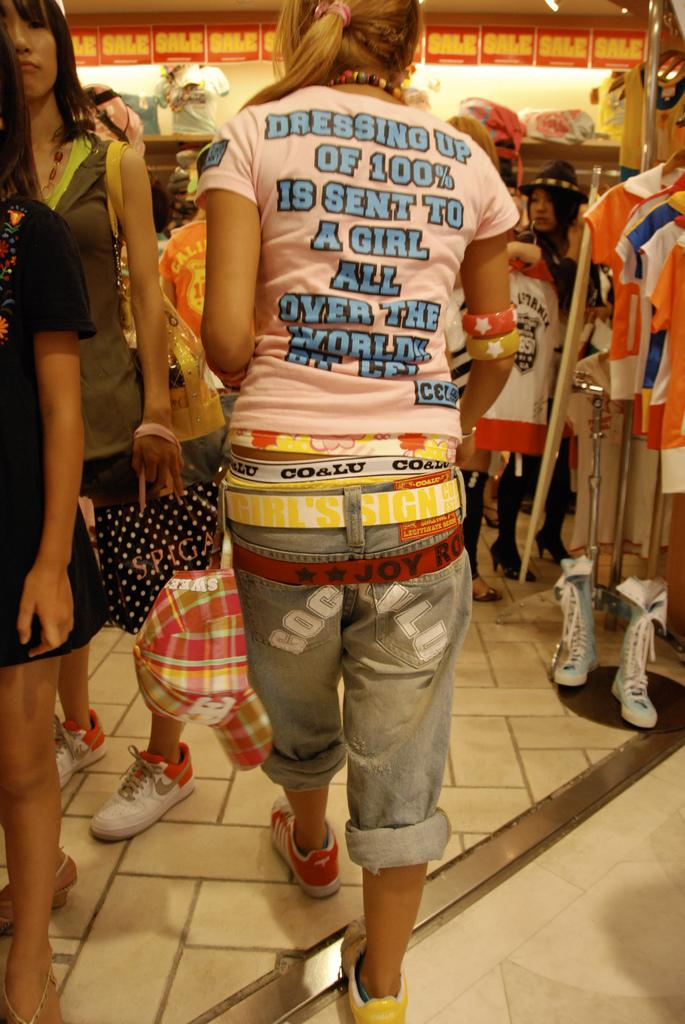Who is present in the image? There is a woman in the image. What is the woman wearing? The woman is wearing a pink t-shirt. Where is the woman located in the image? The woman is walking in a cloth store. Can you describe the background of the image? There are people visible in the background of the image. What can be seen in the right corner of the image? There are clothes on a stand in the right corner of the image. What type of sea creature can be seen swimming in the image? There is no sea creature present in the image; it is set in a cloth store. 